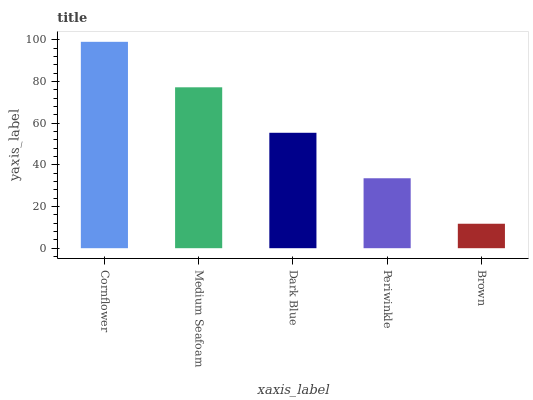Is Brown the minimum?
Answer yes or no. Yes. Is Cornflower the maximum?
Answer yes or no. Yes. Is Medium Seafoam the minimum?
Answer yes or no. No. Is Medium Seafoam the maximum?
Answer yes or no. No. Is Cornflower greater than Medium Seafoam?
Answer yes or no. Yes. Is Medium Seafoam less than Cornflower?
Answer yes or no. Yes. Is Medium Seafoam greater than Cornflower?
Answer yes or no. No. Is Cornflower less than Medium Seafoam?
Answer yes or no. No. Is Dark Blue the high median?
Answer yes or no. Yes. Is Dark Blue the low median?
Answer yes or no. Yes. Is Cornflower the high median?
Answer yes or no. No. Is Periwinkle the low median?
Answer yes or no. No. 